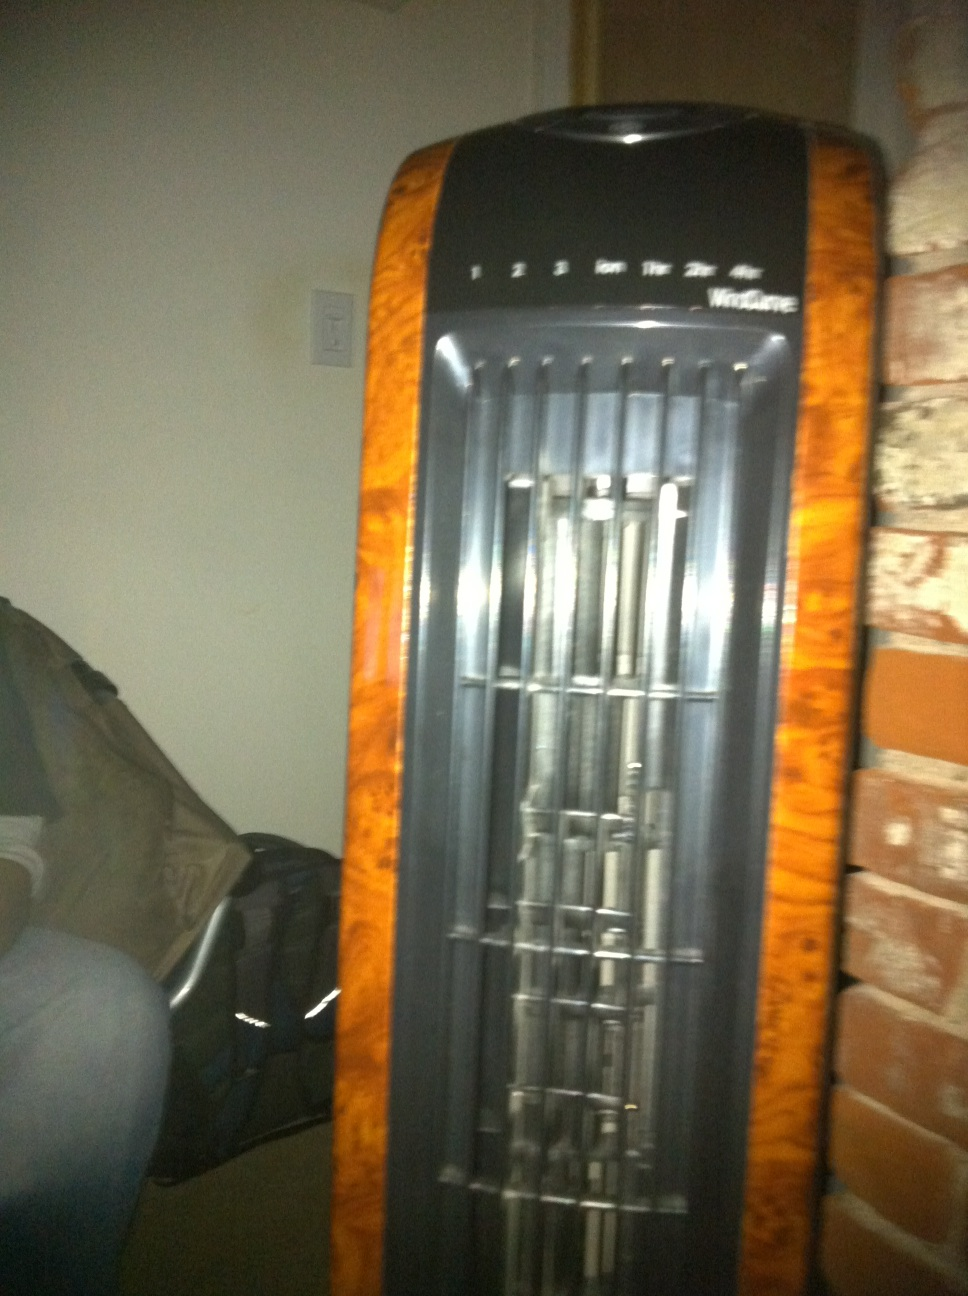How does this fan work? This fan likely operates by drawing in air through the vents located on its sides or back and then pushing it out through the front grille. The speed settings on the top of the fan allow you to adjust the airflow intensity. Tower fans are designed to be space-efficient while providing effective cooling. 